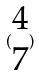<formula> <loc_0><loc_0><loc_500><loc_500>( \begin{matrix} 4 \\ 7 \end{matrix} )</formula> 